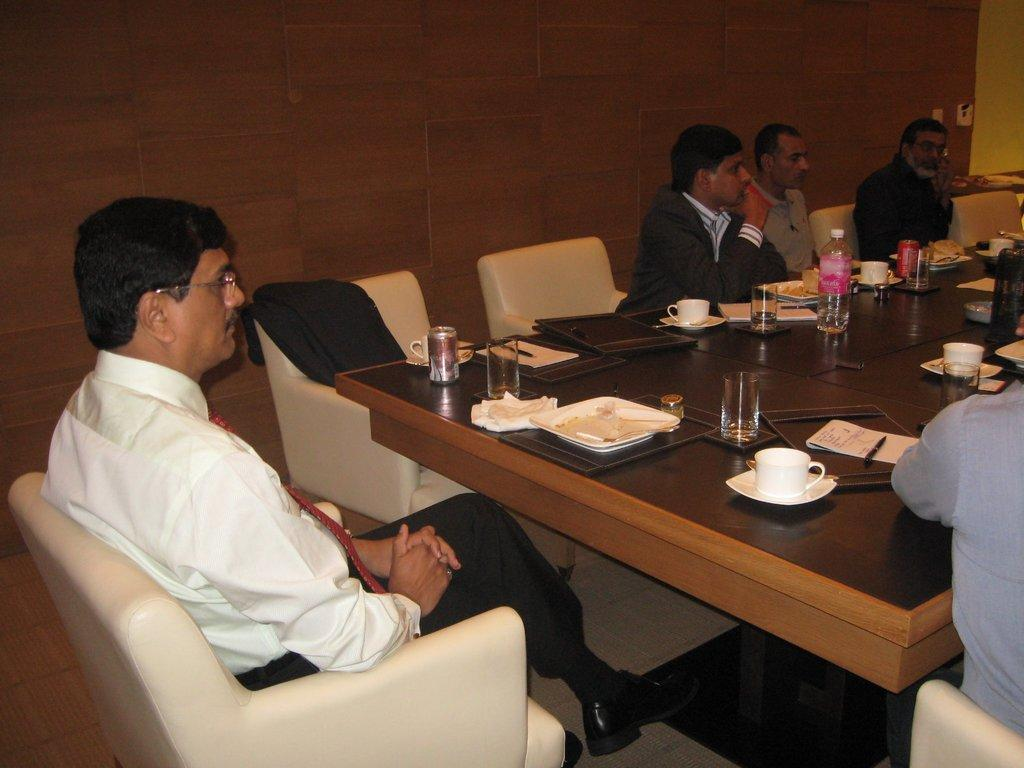What is the man in the image doing? The man is sitting on a chair in the image. What is located near the man? There is a table in the image. What items can be seen on the table? The table has cups, saucers, plates, glasses, papers, a pen, and a water bottle. Are there any other people present in the image? Yes, there are other men sitting at the table. How many times does the man in the middle sneeze during the meeting? There is no indication of a meeting or sneezing in the image, and the man's position relative to the others is not specified. 